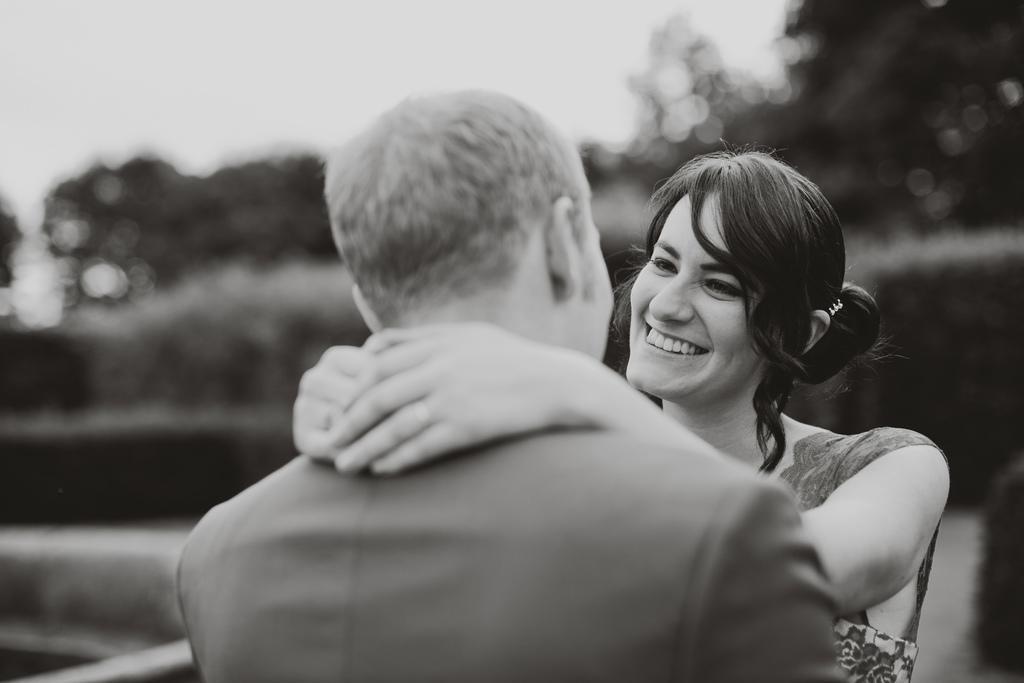Please provide a concise description of this image. This is a black and white image in this image there is a man and a woman, in the background it is blurred. 